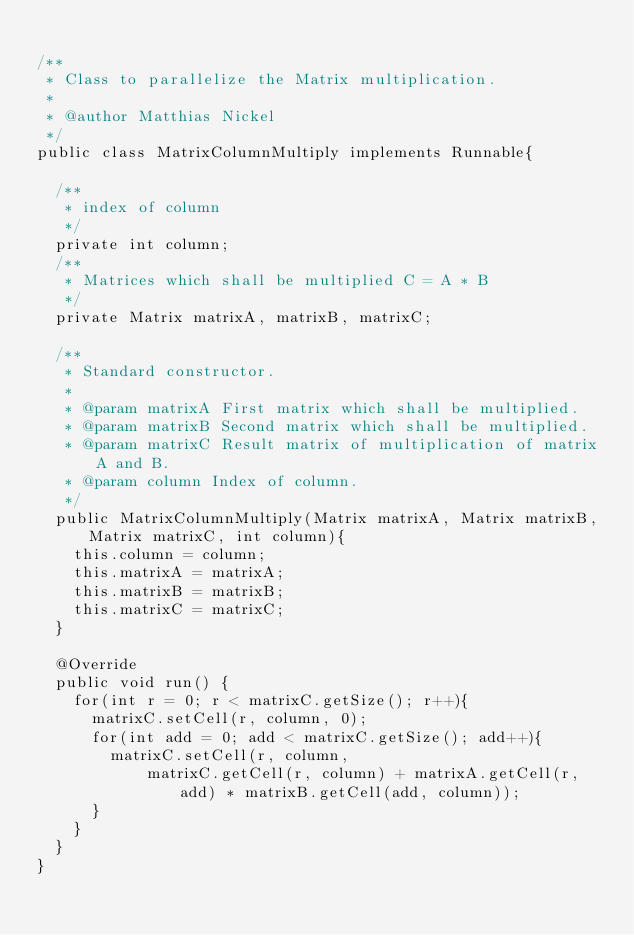Convert code to text. <code><loc_0><loc_0><loc_500><loc_500><_Java_>
/**
 * Class to parallelize the Matrix multiplication.
 * 
 * @author Matthias Nickel
 */
public class MatrixColumnMultiply implements Runnable{
	
	/**
	 * index of column
	 */
	private int column;
	/**
	 * Matrices which shall be multiplied C = A * B
	 */
	private Matrix matrixA, matrixB, matrixC;
	
	/**
	 * Standard constructor.
	 * 
	 * @param matrixA First matrix which shall be multiplied.
	 * @param matrixB Second matrix which shall be multiplied.
	 * @param matrixC Result matrix of multiplication of matrix A and B.
	 * @param column Index of column.
	 */
	public MatrixColumnMultiply(Matrix matrixA, Matrix matrixB, Matrix matrixC, int column){
		this.column = column;
		this.matrixA = matrixA;
		this.matrixB = matrixB;
		this.matrixC = matrixC;
	}

	@Override
	public void run() {
		for(int r = 0; r < matrixC.getSize(); r++){
			matrixC.setCell(r, column, 0);
			for(int add = 0; add < matrixC.getSize(); add++){
				matrixC.setCell(r, column, 
						matrixC.getCell(r, column) + matrixA.getCell(r, add) * matrixB.getCell(add, column));
			}
		}
	}
}
</code> 